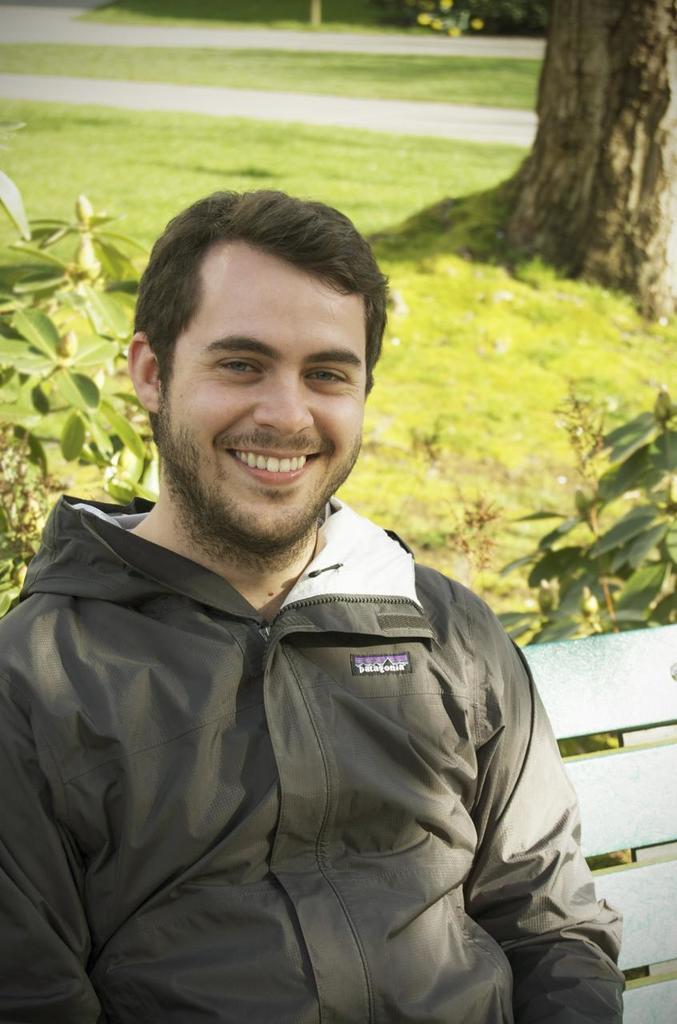Can you describe this image briefly? As we can see in the image in the front there is a man wearing black color jacket and sitting on bench. There is a grass, plant and tree stem. 